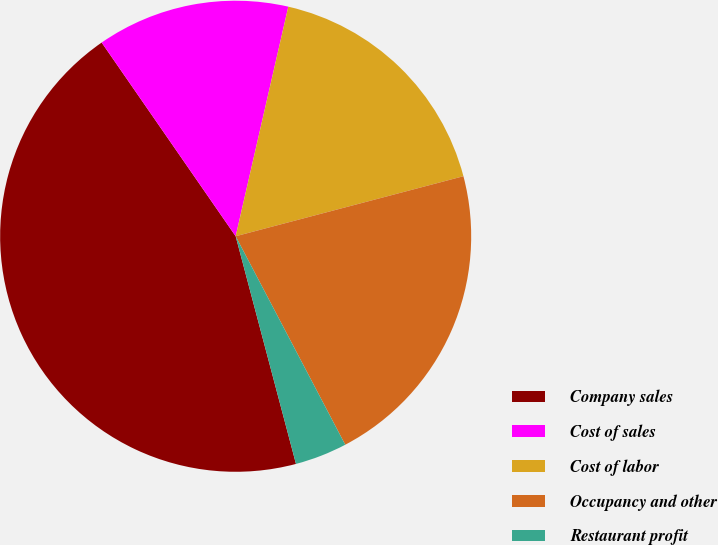<chart> <loc_0><loc_0><loc_500><loc_500><pie_chart><fcel>Company sales<fcel>Cost of sales<fcel>Cost of labor<fcel>Occupancy and other<fcel>Restaurant profit<nl><fcel>44.49%<fcel>13.22%<fcel>17.31%<fcel>21.4%<fcel>3.58%<nl></chart> 